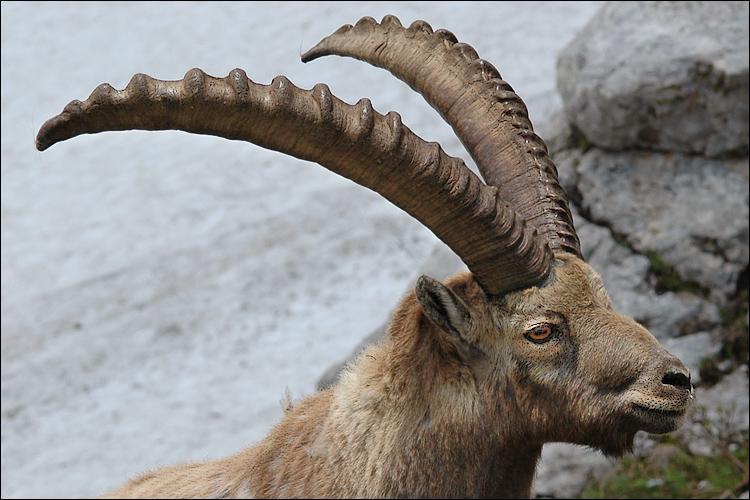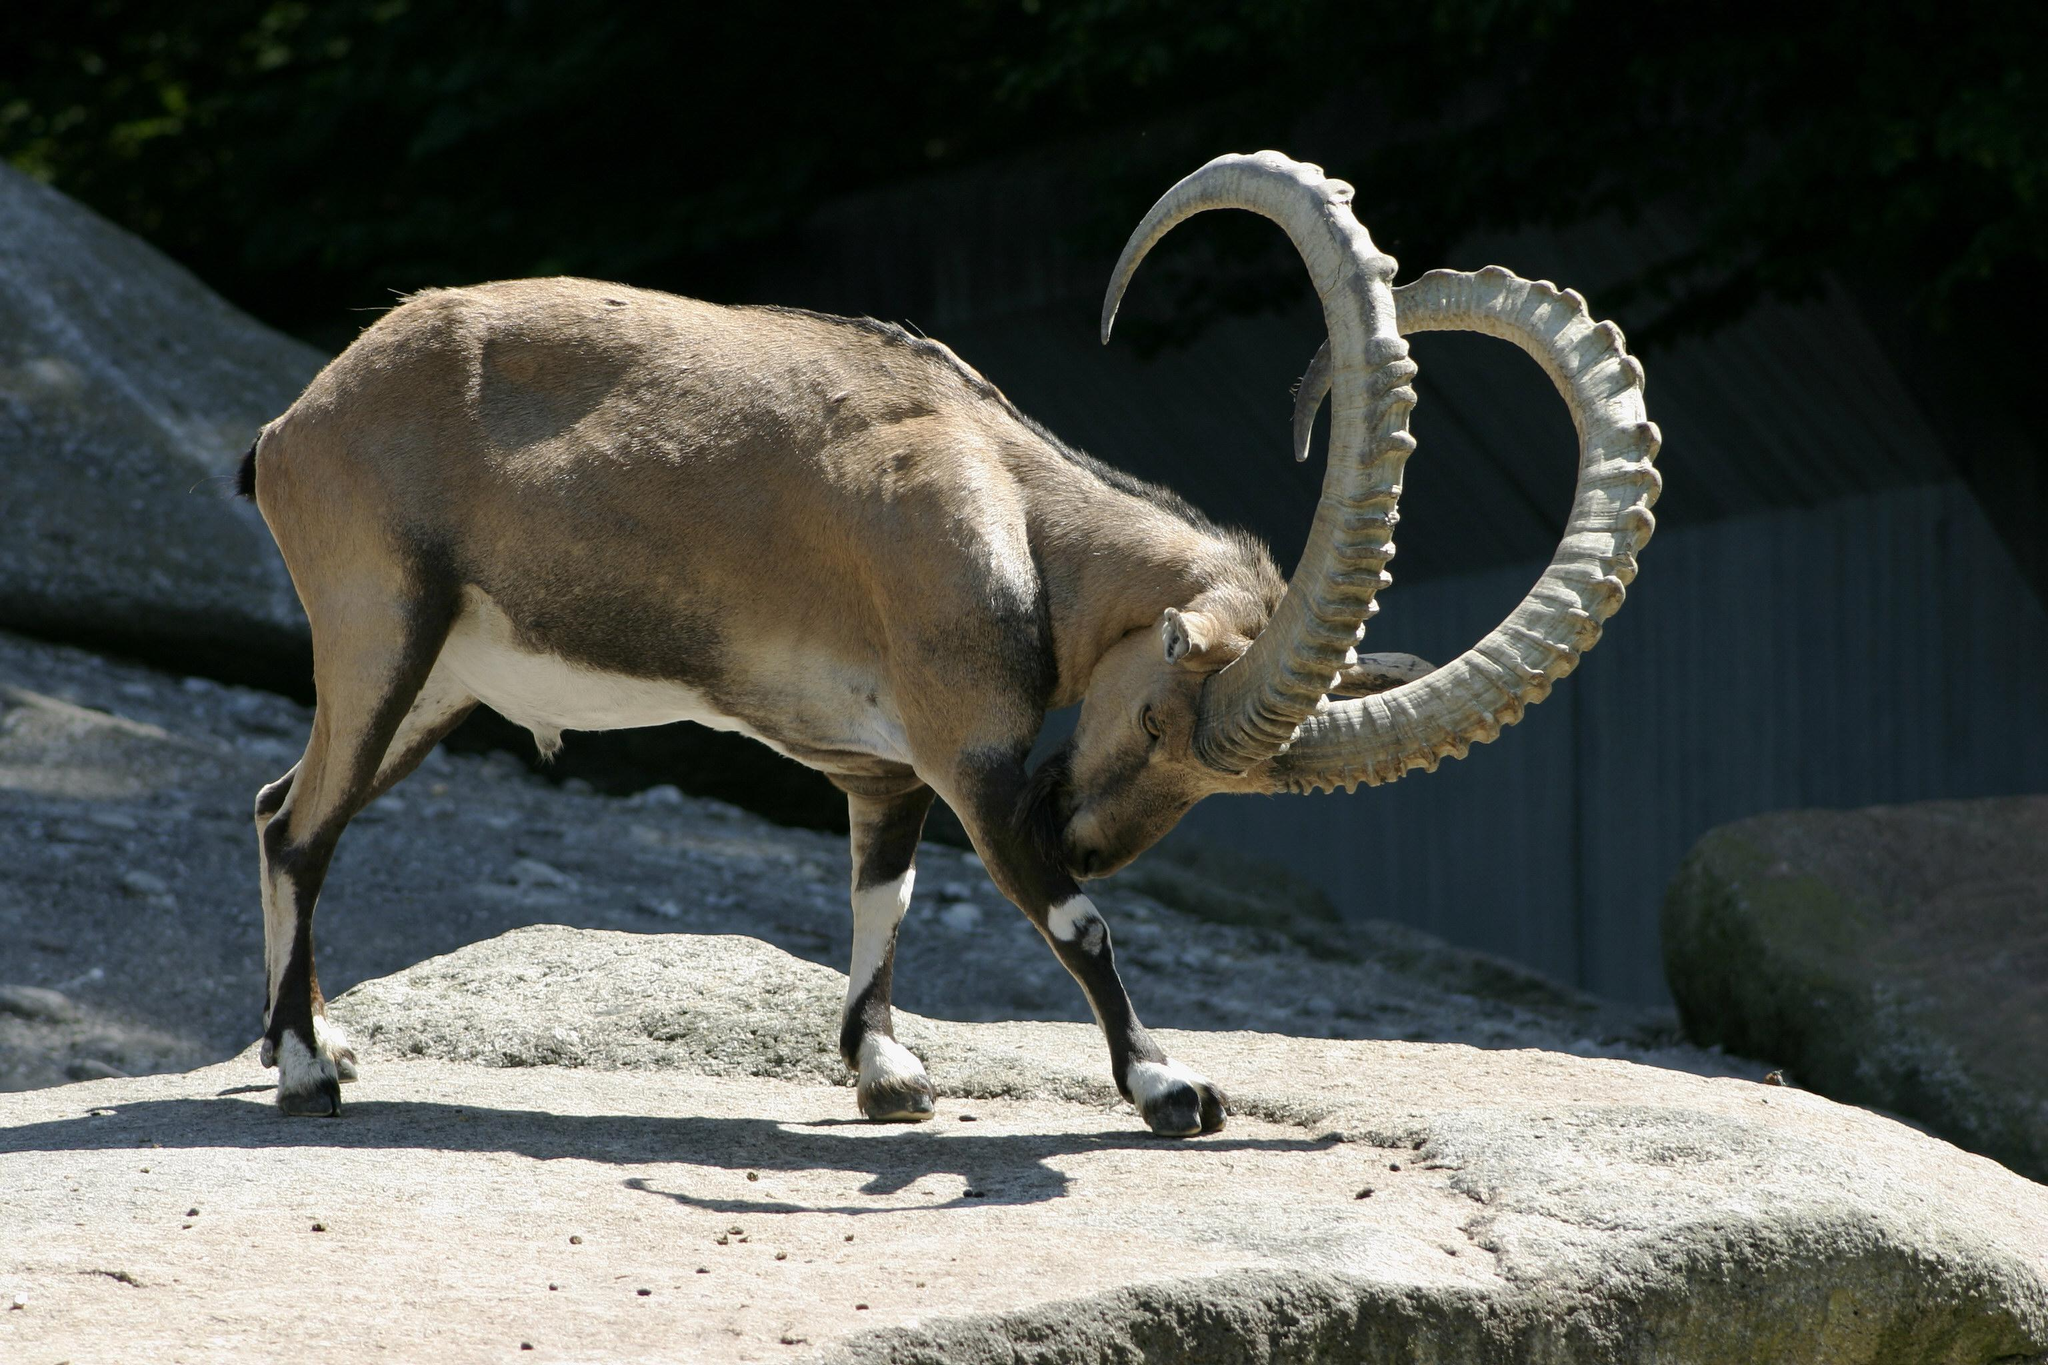The first image is the image on the left, the second image is the image on the right. Given the left and right images, does the statement "One image contains more than one animal." hold true? Answer yes or no. No. The first image is the image on the left, the second image is the image on the right. For the images displayed, is the sentence "There is exactly one animal in the image on the right." factually correct? Answer yes or no. Yes. 